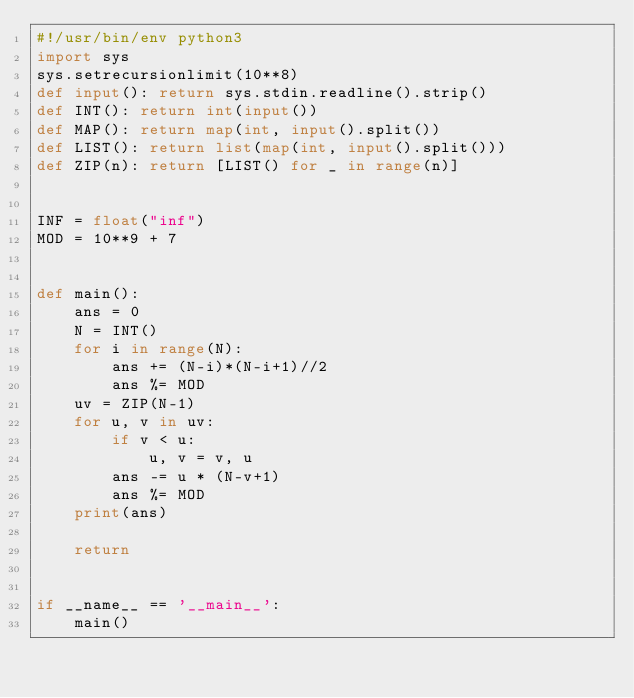Convert code to text. <code><loc_0><loc_0><loc_500><loc_500><_Python_>#!/usr/bin/env python3
import sys
sys.setrecursionlimit(10**8)
def input(): return sys.stdin.readline().strip()
def INT(): return int(input())
def MAP(): return map(int, input().split())
def LIST(): return list(map(int, input().split()))
def ZIP(n): return [LIST() for _ in range(n)]


INF = float("inf")
MOD = 10**9 + 7


def main():
    ans = 0
    N = INT()
    for i in range(N):
        ans += (N-i)*(N-i+1)//2
        ans %= MOD
    uv = ZIP(N-1)
    for u, v in uv:
        if v < u:
            u, v = v, u
        ans -= u * (N-v+1)
        ans %= MOD
    print(ans)

    return


if __name__ == '__main__':
    main()
</code> 